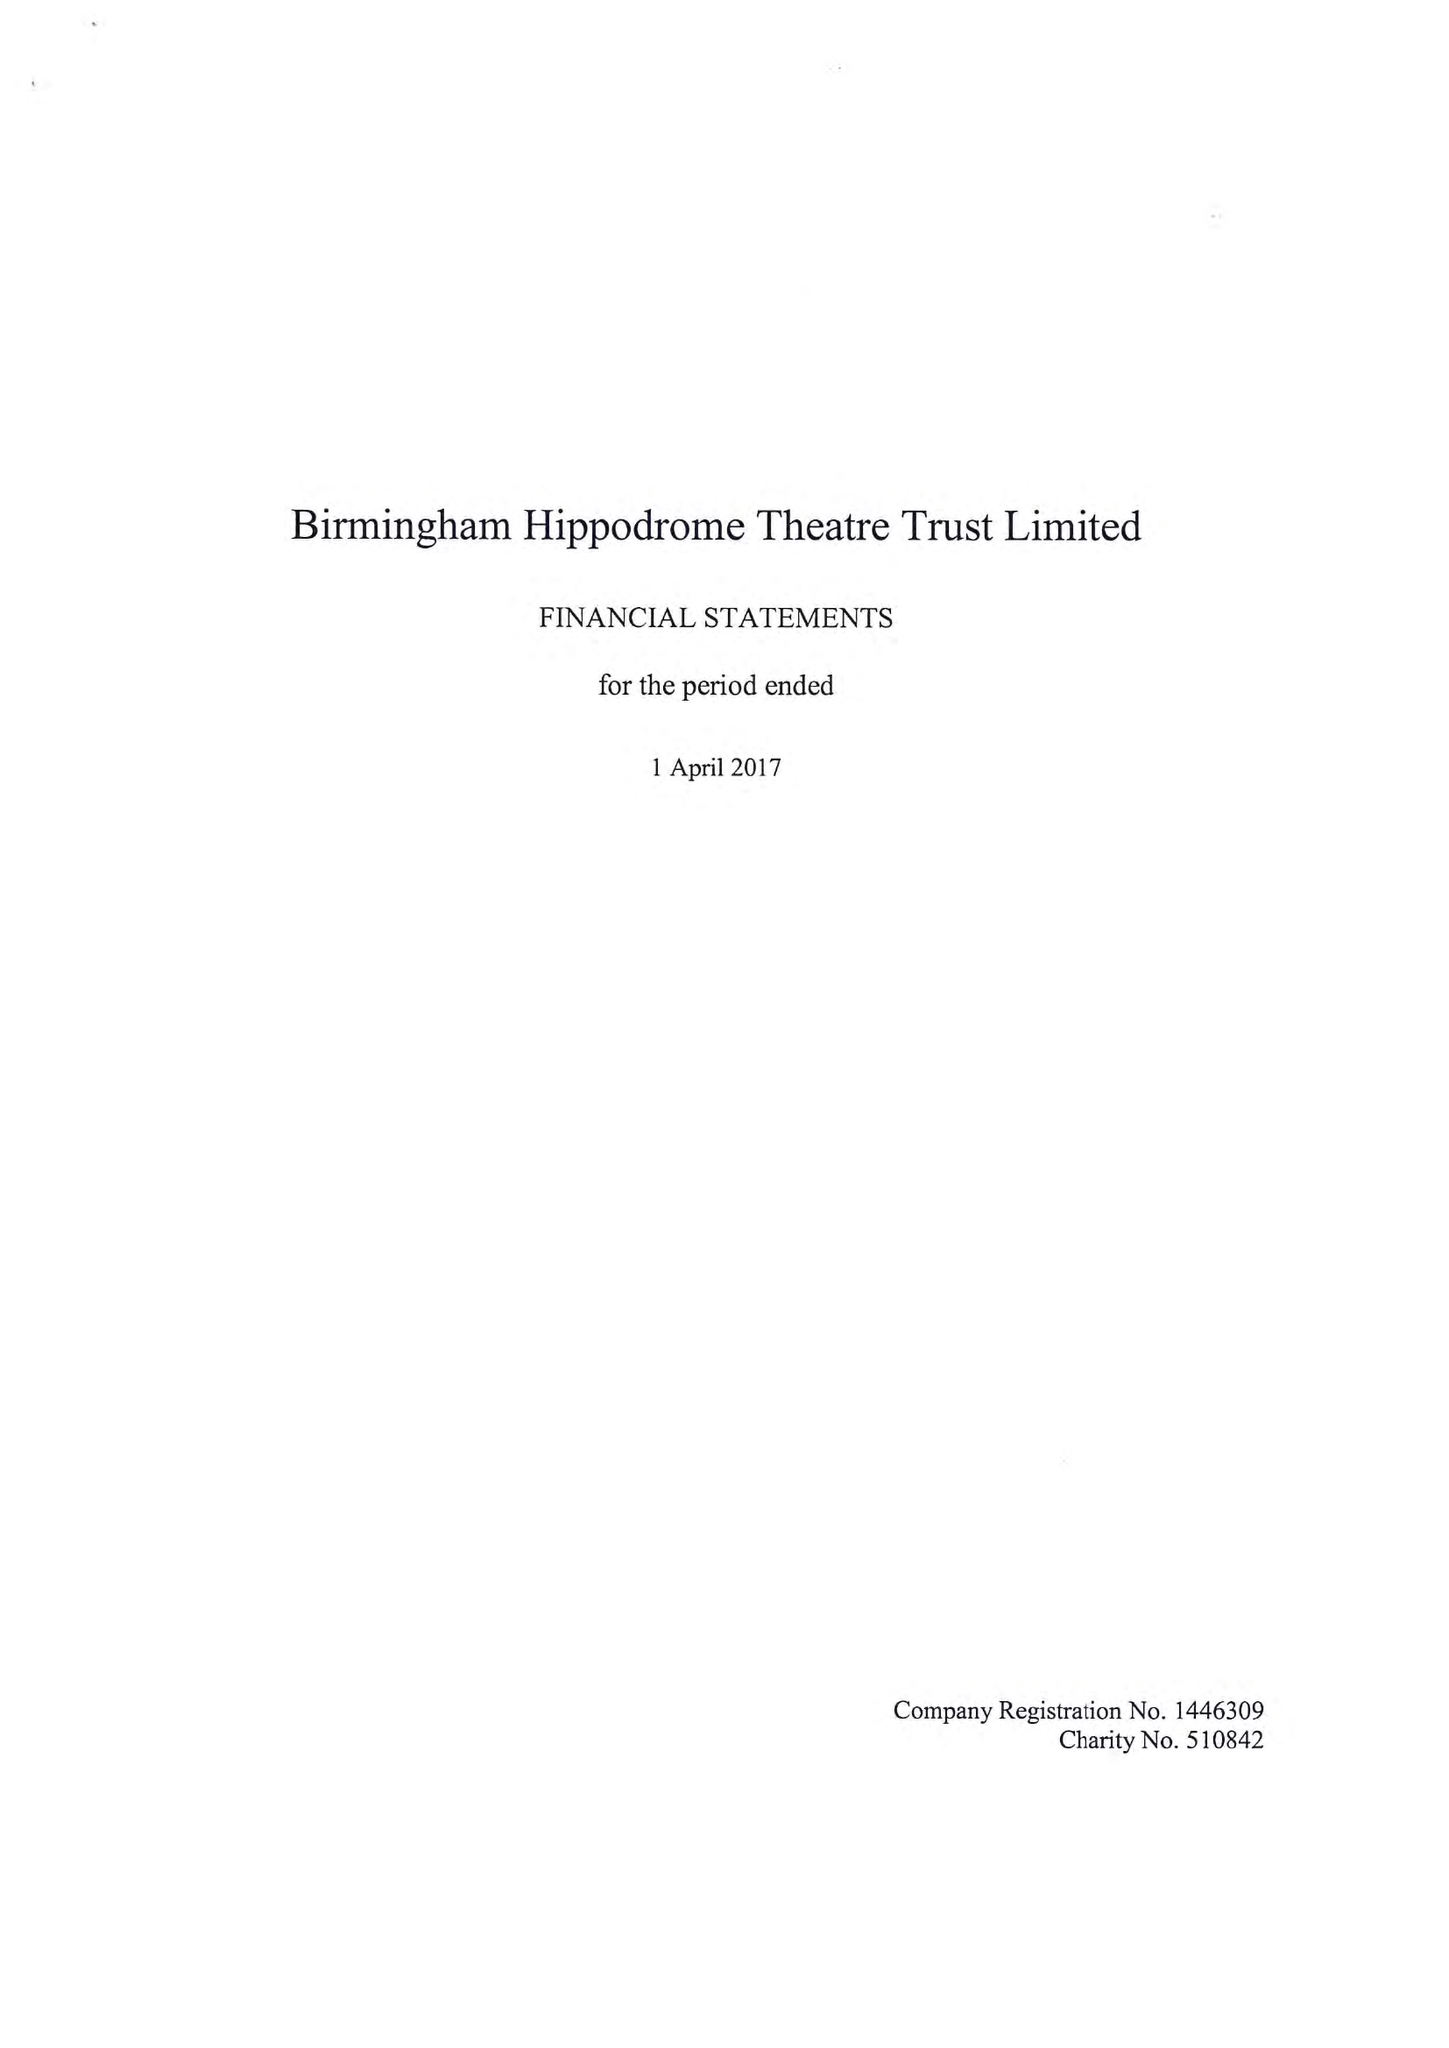What is the value for the charity_number?
Answer the question using a single word or phrase. 510842 